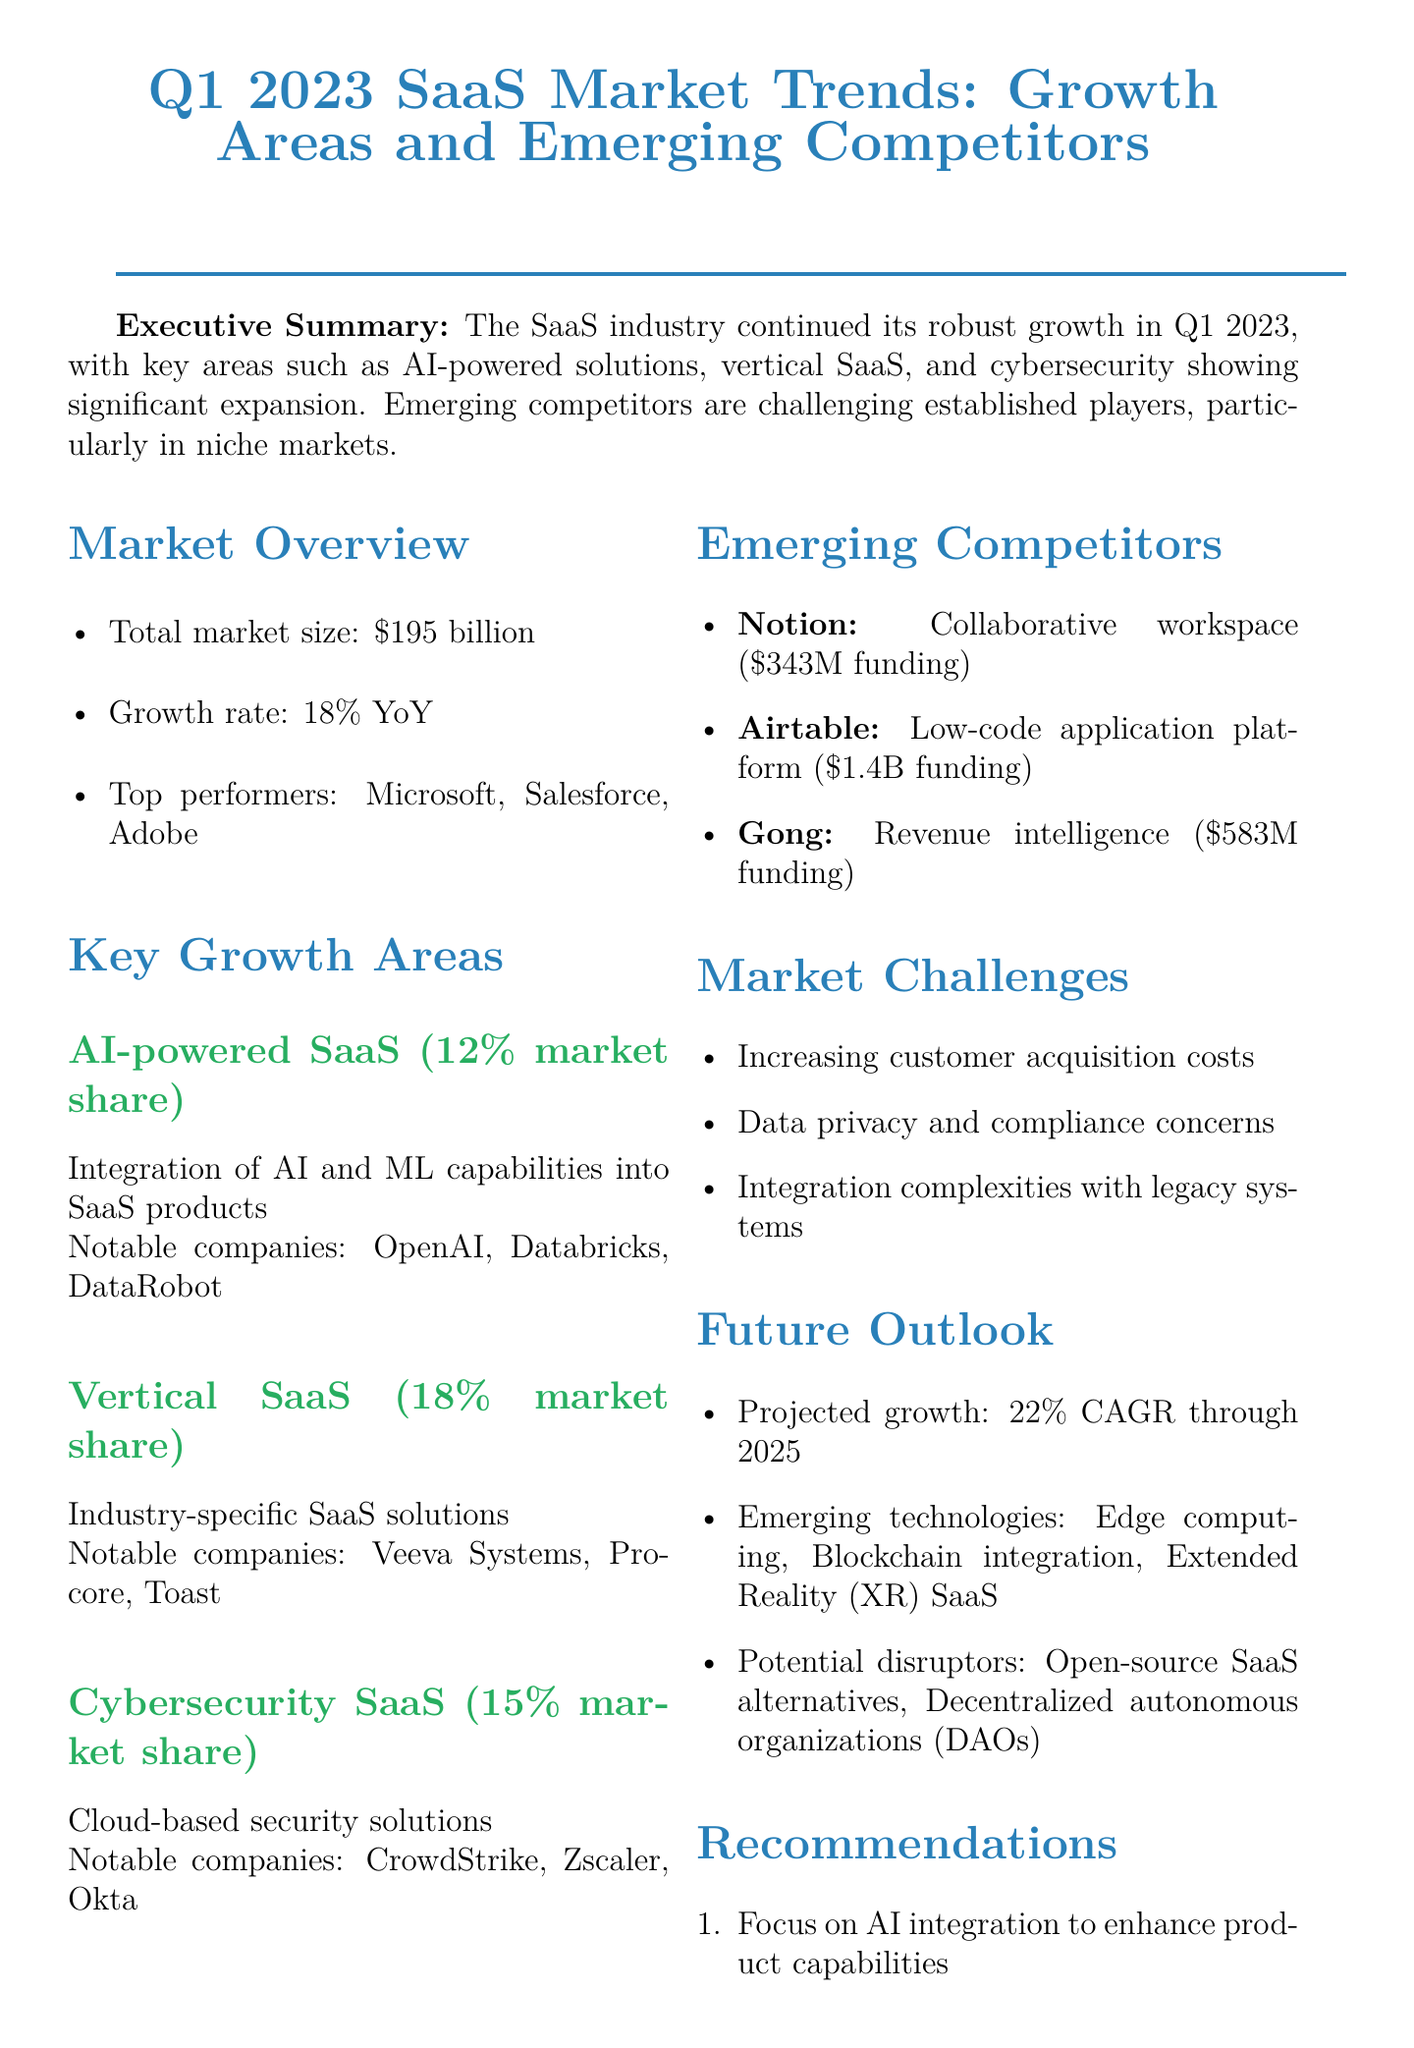what is the total market size of the SaaS industry? The total market size is stated clearly in the Market Overview section of the document.
Answer: $195 billion what is the YoY growth rate for the SaaS market? The growth rate is explicitly mentioned in the Market Overview section, indicating how fast the market is expanding.
Answer: 18% which company has the highest funding among the emerging competitors? The funding amounts for the emerging competitors are provided in the Emerging Competitors section, allowing identification of the one with the highest amount.
Answer: Airtable what percentage of the SaaS market does vertical SaaS hold? The document specifies the market share in the Key Growth Areas section, specifically for vertical SaaS.
Answer: 18% of total SaaS market name one key challenge facing the SaaS market. The challenges are listed in the Market Challenges section of the document, highlighting current issues affecting the industry.
Answer: Increasing customer acquisition costs how do emerging competitors affect established players? The Executive Summary discusses the impact of emerging competitors on existing market leaders, particularly in niche areas.
Answer: Challenging what is the projected CAGR for the SaaS market through 2025? The future growth outlook is provided in the Future Outlook section, specifying the annual growth prediction.
Answer: 22% CAGR which area is focused on integrating artificial intelligence into SaaS products? The Key Growth Areas section contains specific mentions of growth areas, which helps to identify this particular focus.
Answer: AI-powered SaaS 